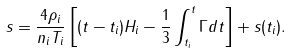Convert formula to latex. <formula><loc_0><loc_0><loc_500><loc_500>s = \frac { 4 \rho _ { i } } { n _ { i } T _ { i } } \left [ ( t - t _ { i } ) H _ { i } - \frac { 1 } { 3 } \int _ { t _ { i } } ^ { t } \Gamma d t \right ] + s ( t _ { i } ) .</formula> 